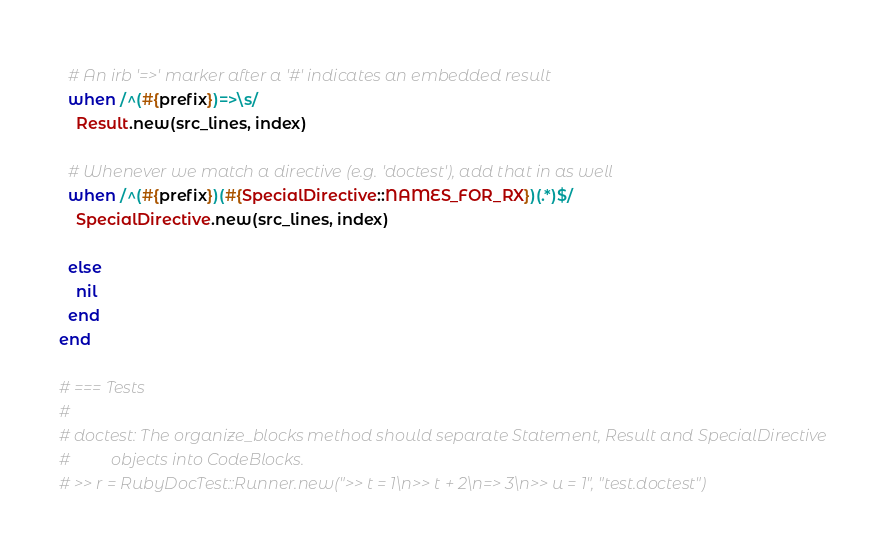Convert code to text. <code><loc_0><loc_0><loc_500><loc_500><_Ruby_>      
      # An irb '=>' marker after a '#' indicates an embedded result
      when /^(#{prefix})=>\s/
        Result.new(src_lines, index)
      
      # Whenever we match a directive (e.g. 'doctest'), add that in as well
      when /^(#{prefix})(#{SpecialDirective::NAMES_FOR_RX})(.*)$/
        SpecialDirective.new(src_lines, index)
      
      else
        nil
      end
    end
    
    # === Tests
    # 
    # doctest: The organize_blocks method should separate Statement, Result and SpecialDirective
    #          objects into CodeBlocks.
    # >> r = RubyDocTest::Runner.new(">> t = 1\n>> t + 2\n=> 3\n>> u = 1", "test.doctest")</code> 